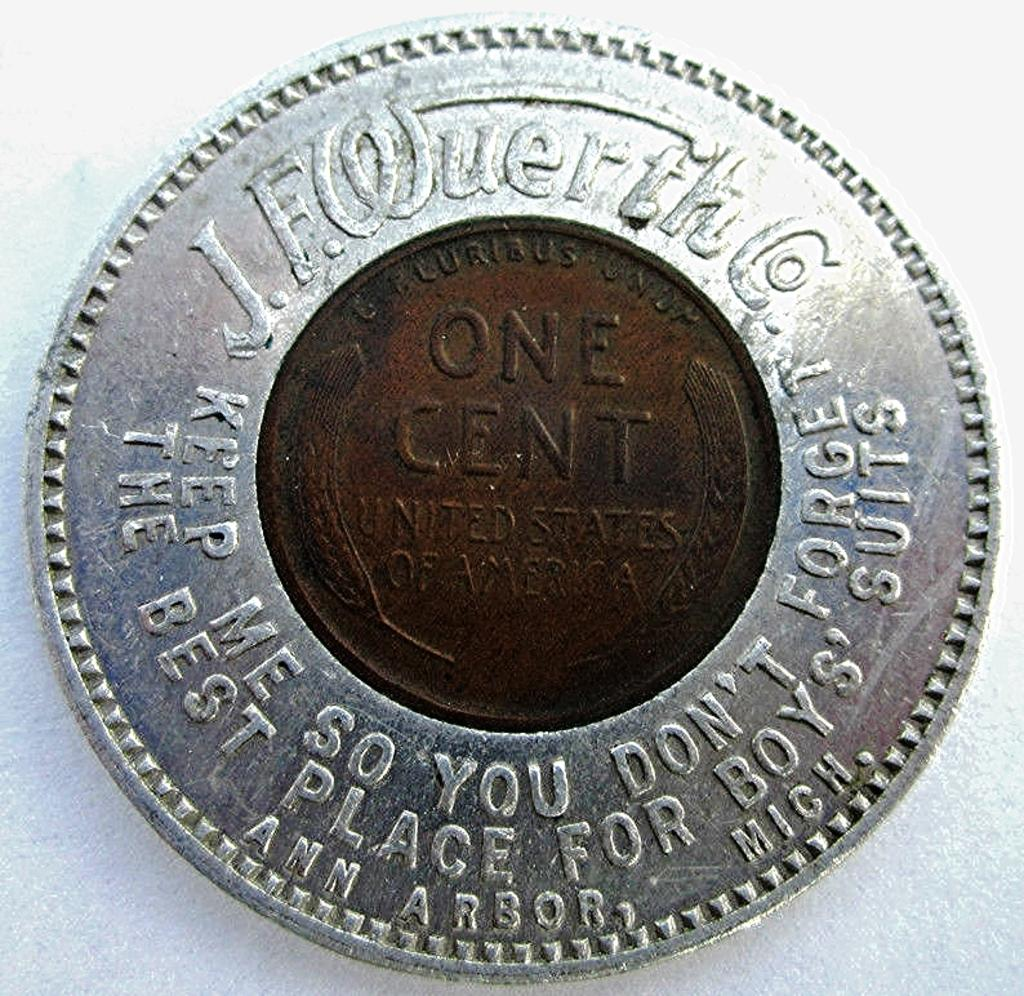<image>
Write a terse but informative summary of the picture. A copper one cent coin in the middle of a J. F. Wuerth Co. coin 